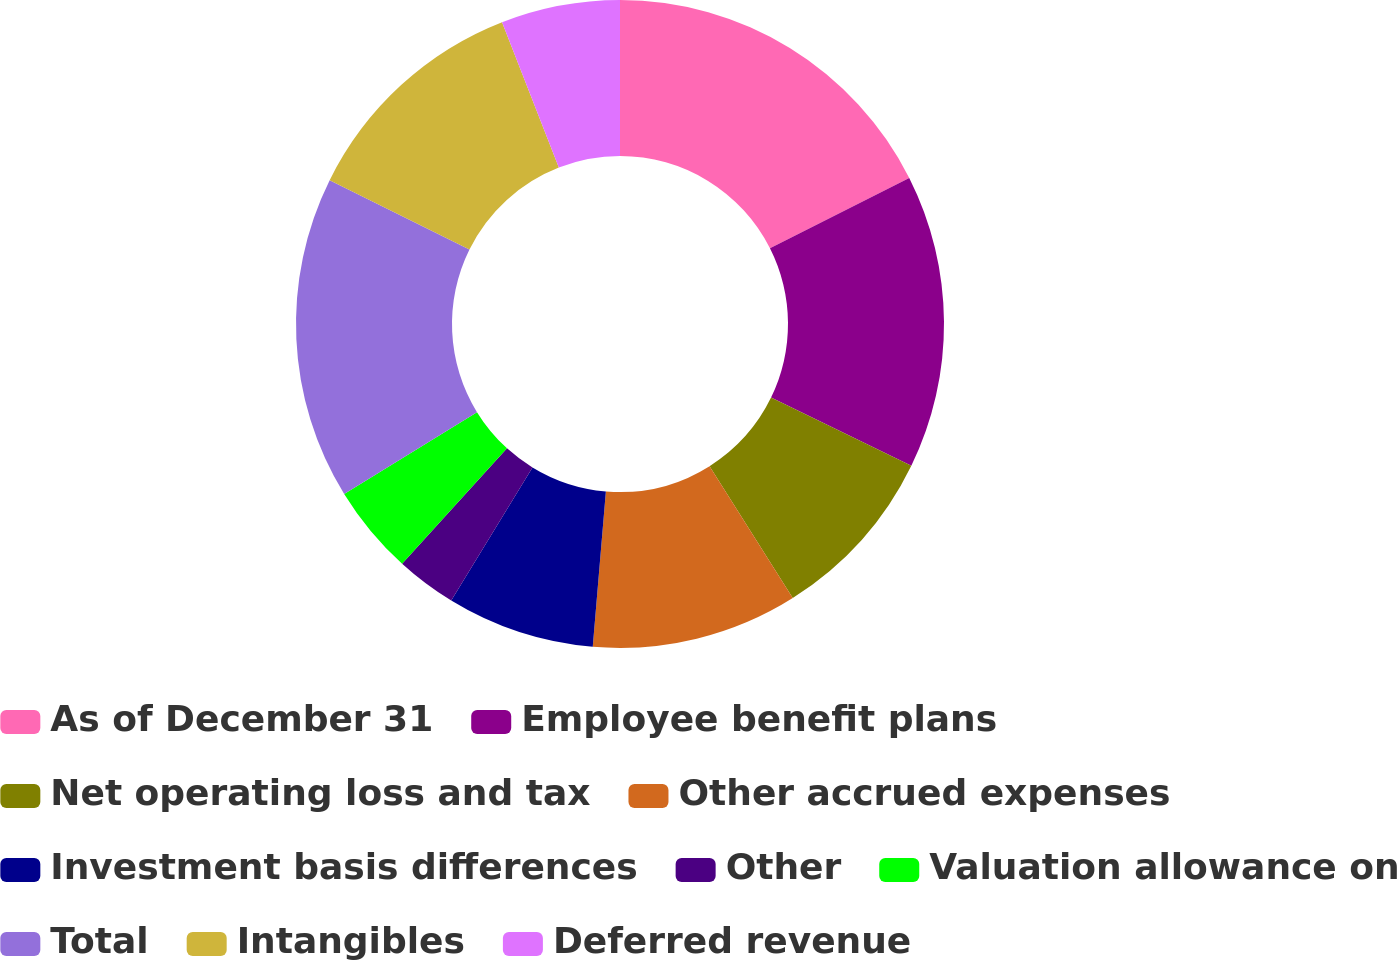<chart> <loc_0><loc_0><loc_500><loc_500><pie_chart><fcel>As of December 31<fcel>Employee benefit plans<fcel>Net operating loss and tax<fcel>Other accrued expenses<fcel>Investment basis differences<fcel>Other<fcel>Valuation allowance on<fcel>Total<fcel>Intangibles<fcel>Deferred revenue<nl><fcel>17.56%<fcel>14.65%<fcel>8.84%<fcel>10.29%<fcel>7.38%<fcel>3.02%<fcel>4.47%<fcel>16.11%<fcel>11.75%<fcel>5.93%<nl></chart> 